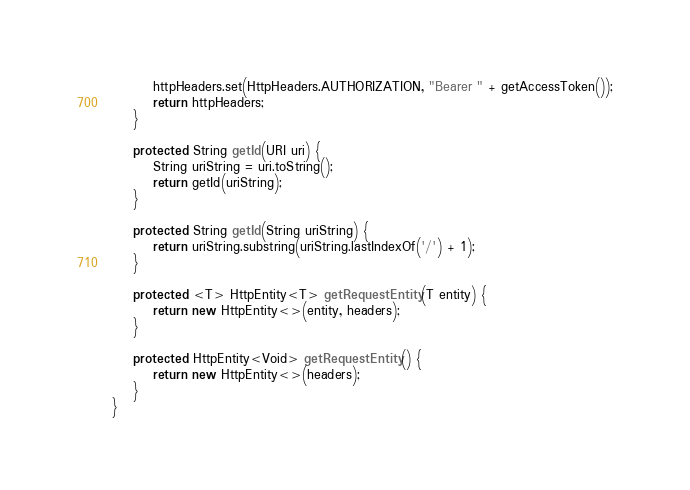Convert code to text. <code><loc_0><loc_0><loc_500><loc_500><_Java_>        httpHeaders.set(HttpHeaders.AUTHORIZATION, "Bearer " + getAccessToken());
        return httpHeaders;
    }

    protected String getId(URI uri) {
        String uriString = uri.toString();
        return getId(uriString);
    }

    protected String getId(String uriString) {
        return uriString.substring(uriString.lastIndexOf('/') + 1);
    }

    protected <T> HttpEntity<T> getRequestEntity(T entity) {
        return new HttpEntity<>(entity, headers);
    }

    protected HttpEntity<Void> getRequestEntity() {
        return new HttpEntity<>(headers);
    }
}
</code> 